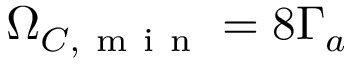<formula> <loc_0><loc_0><loc_500><loc_500>\Omega _ { C , m i n } = 8 \Gamma _ { a }</formula> 